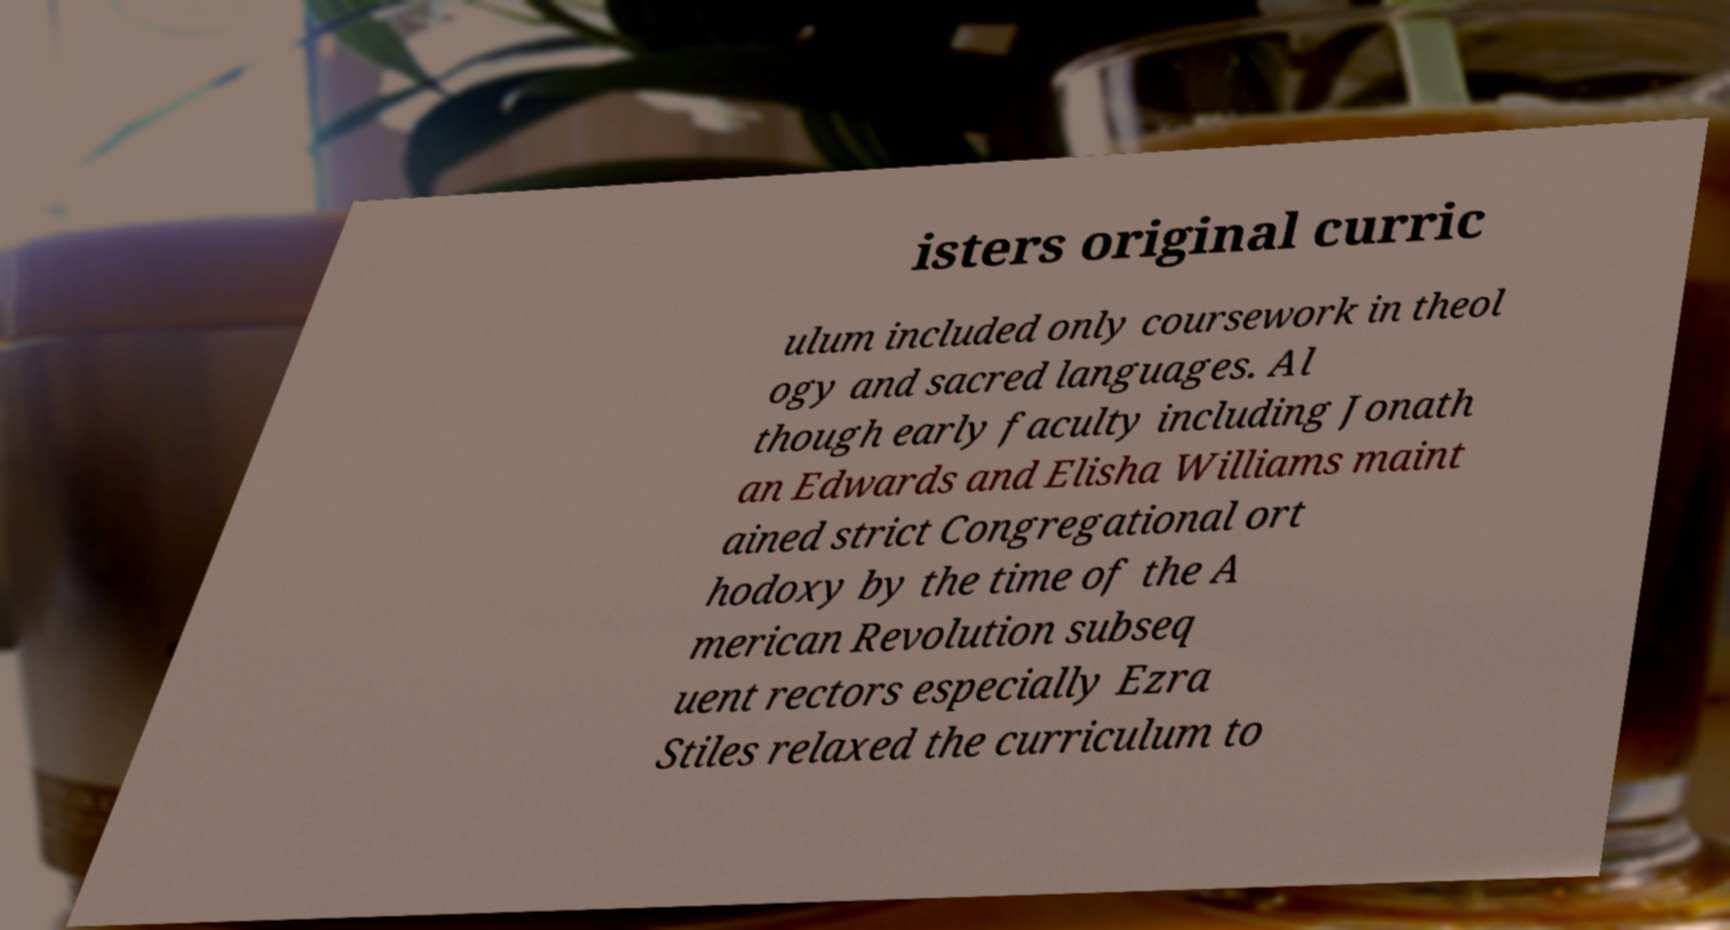What messages or text are displayed in this image? I need them in a readable, typed format. isters original curric ulum included only coursework in theol ogy and sacred languages. Al though early faculty including Jonath an Edwards and Elisha Williams maint ained strict Congregational ort hodoxy by the time of the A merican Revolution subseq uent rectors especially Ezra Stiles relaxed the curriculum to 